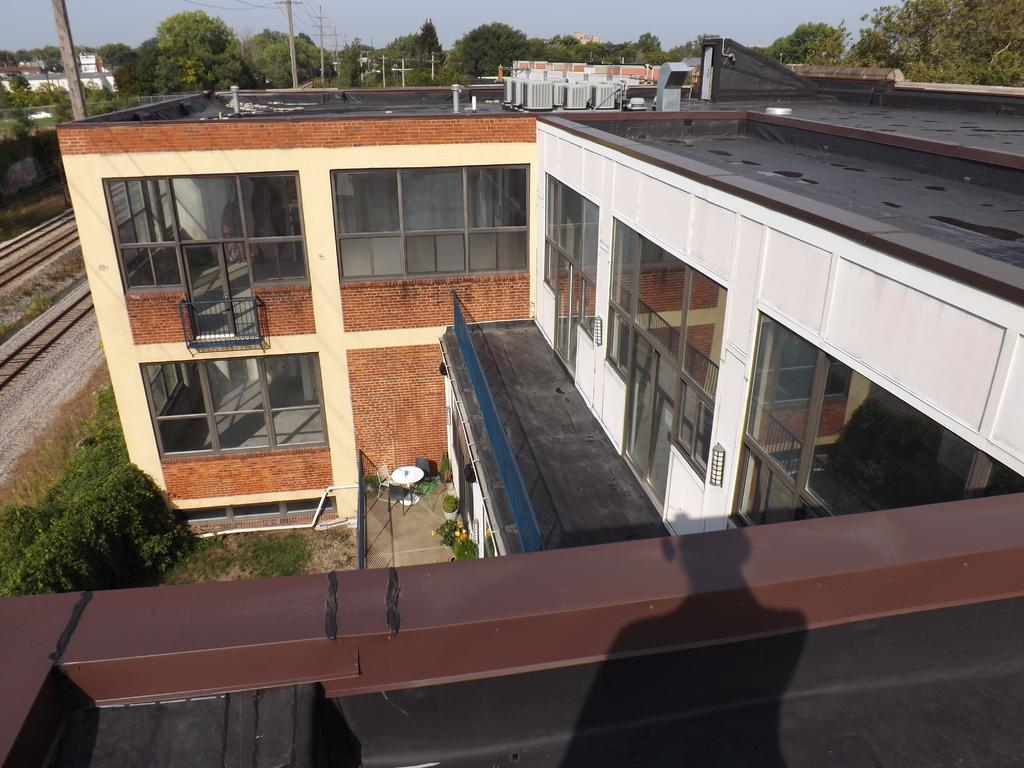What type of vegetation can be seen in the image? There are trees in the image. What type of structures are visible in the image? There are buildings in the image. What objects can be seen in the top left of the image? There are poles in the top left of the image. What is visible at the top of the image? The sky is visible at the top of the image. What type of grape is growing on the trees in the image? There are no grapes present in the image; it features trees and buildings. What is the condition of the office in the image? There is no office present in the image. 